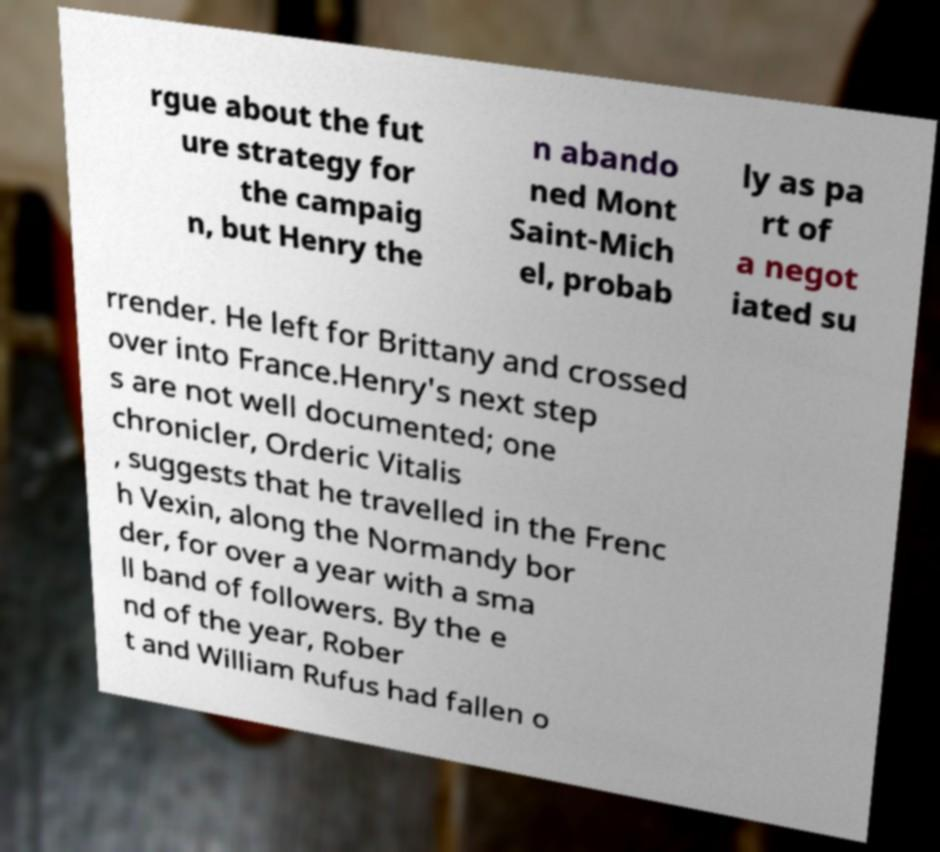There's text embedded in this image that I need extracted. Can you transcribe it verbatim? rgue about the fut ure strategy for the campaig n, but Henry the n abando ned Mont Saint-Mich el, probab ly as pa rt of a negot iated su rrender. He left for Brittany and crossed over into France.Henry's next step s are not well documented; one chronicler, Orderic Vitalis , suggests that he travelled in the Frenc h Vexin, along the Normandy bor der, for over a year with a sma ll band of followers. By the e nd of the year, Rober t and William Rufus had fallen o 